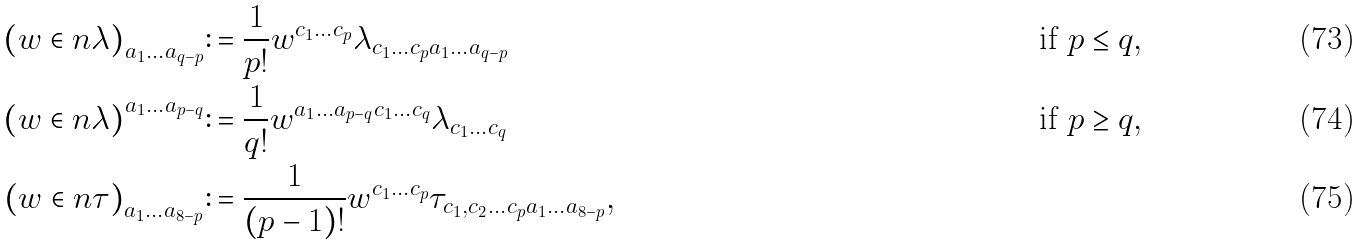<formula> <loc_0><loc_0><loc_500><loc_500>\left ( w \in n \lambda \right ) _ { a _ { 1 } \dots a _ { q - p } } & \colon = \frac { 1 } { p ! } w ^ { c _ { 1 } \dots c _ { p } } \lambda _ { c _ { 1 } \dots c _ { p } a _ { 1 } \dots a _ { q - p } } & & & & \text {if $p\leq q$} , \\ \left ( w \in n \lambda \right ) ^ { a _ { 1 } \dots a _ { p - q } } & \colon = \frac { 1 } { q ! } w ^ { a _ { 1 } \dots a _ { p - q } c _ { 1 } \dots c _ { q } } \lambda _ { c _ { 1 } \dots c _ { q } } & & & & \text {if $p \geq q$} , \\ \left ( w \in n \tau \right ) _ { a _ { 1 } \dots a _ { 8 - p } } & \colon = \frac { 1 } { ( p - 1 ) ! } w ^ { c _ { 1 } \dots c _ { p } } \tau _ { c _ { 1 } , c _ { 2 } \dots c _ { p } a _ { 1 } \dots a _ { 8 - p } } ,</formula> 